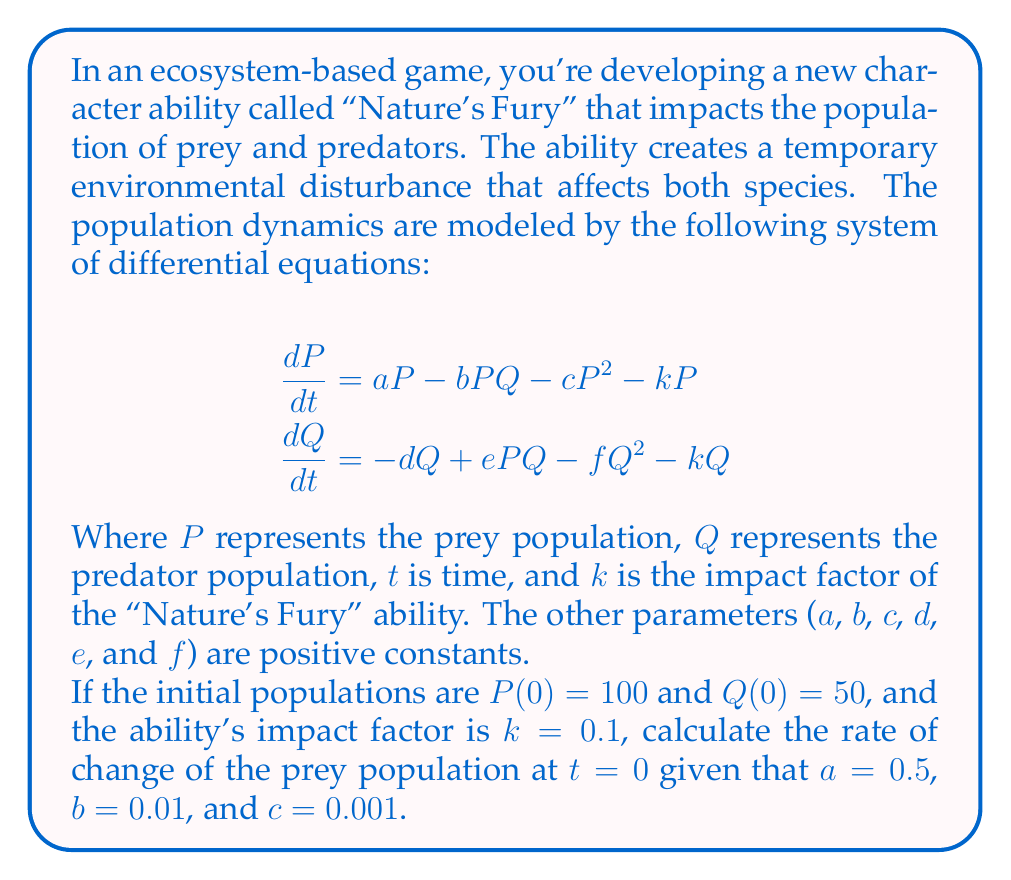Could you help me with this problem? To solve this problem, we need to use the given differential equation for the prey population and substitute the known values. Let's break it down step by step:

1. The differential equation for the prey population is:

   $$\frac{dP}{dt} = aP - bPQ - cP^2 - kP$$

2. We're given the following values:
   - $P(0) = 100$ (initial prey population)
   - $Q(0) = 50$ (initial predator population)
   - $k = 0.1$ (impact factor of the ability)
   - $a = 0.5$
   - $b = 0.01$
   - $c = 0.001$

3. We need to calculate $\frac{dP}{dt}$ at $t = 0$, so we'll substitute these values into the equation:

   $$\begin{align}
   \frac{dP}{dt} &= aP - bPQ - cP^2 - kP \\
   &= 0.5P - 0.01PQ - 0.001P^2 - 0.1P
   \end{align}$$

4. Now, let's substitute the initial population values:

   $$\begin{align}
   \frac{dP}{dt} &= 0.5(100) - 0.01(100)(50) - 0.001(100)^2 - 0.1(100) \\
   &= 50 - 50 - 10 - 10
   \end{align}$$

5. Calculate the final result:

   $$\frac{dP}{dt} = -20$$

This negative value indicates that the prey population is decreasing at $t = 0$.
Answer: The rate of change of the prey population at $t = 0$ is $\frac{dP}{dt} = -20$. 